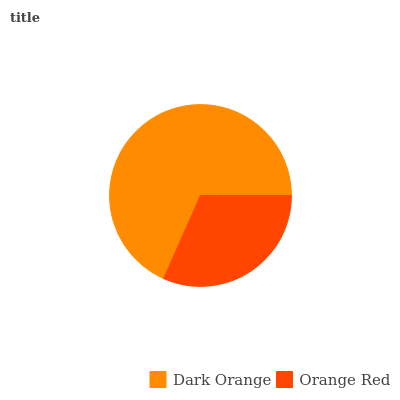Is Orange Red the minimum?
Answer yes or no. Yes. Is Dark Orange the maximum?
Answer yes or no. Yes. Is Orange Red the maximum?
Answer yes or no. No. Is Dark Orange greater than Orange Red?
Answer yes or no. Yes. Is Orange Red less than Dark Orange?
Answer yes or no. Yes. Is Orange Red greater than Dark Orange?
Answer yes or no. No. Is Dark Orange less than Orange Red?
Answer yes or no. No. Is Dark Orange the high median?
Answer yes or no. Yes. Is Orange Red the low median?
Answer yes or no. Yes. Is Orange Red the high median?
Answer yes or no. No. Is Dark Orange the low median?
Answer yes or no. No. 